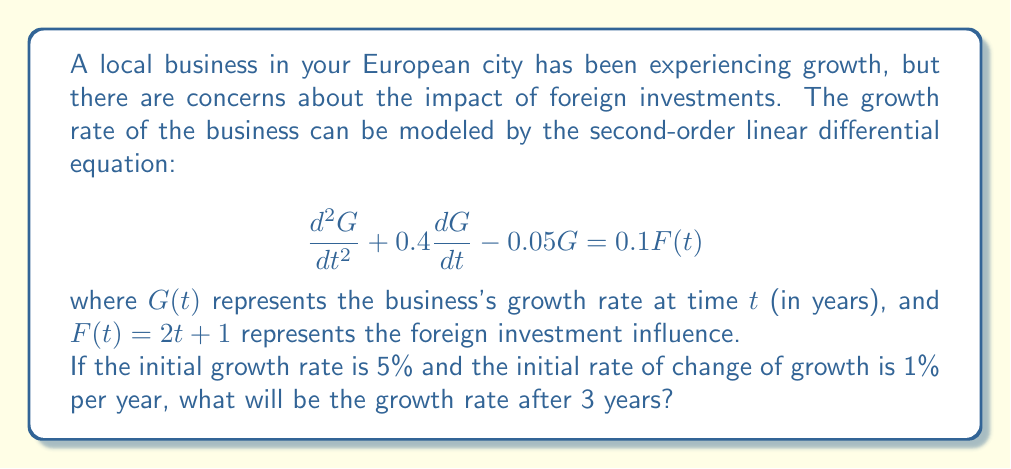Provide a solution to this math problem. To solve this problem, we need to follow these steps:

1) First, we need to find the general solution to the homogeneous equation:

   $$\frac{d^2G}{dt^2} + 0.4\frac{dG}{dt} - 0.05G = 0$$

   The characteristic equation is $r^2 + 0.4r - 0.05 = 0$
   Solving this, we get $r_1 = 0.1$ and $r_2 = -0.5$

   So, the homogeneous solution is:
   $$G_h(t) = c_1e^{0.1t} + c_2e^{-0.5t}$$

2) Now, we need to find a particular solution. Given $F(t) = 2t + 1$, let's assume a particular solution of the form:

   $$G_p(t) = At + B$$

   Substituting this into the original equation:
   
   $$0 + 0.4A - 0.05(At + B) = 0.1(2t + 1)$$

   Equating coefficients:
   $-0.05A = 0.2$
   $0.4A - 0.05B = 0.1$

   Solving these, we get $A = -4$ and $B = -10$

   So, the particular solution is:
   $$G_p(t) = -4t - 10$$

3) The general solution is the sum of the homogeneous and particular solutions:

   $$G(t) = c_1e^{0.1t} + c_2e^{-0.5t} - 4t - 10$$

4) Now we use the initial conditions to find $c_1$ and $c_2$:

   $G(0) = 5$, so $c_1 + c_2 - 10 = 5$
   $G'(0) = 1$, so $0.1c_1 - 0.5c_2 - 4 = 1$

   Solving these equations, we get $c_1 = 20$ and $c_2 = -5$

5) Therefore, the final solution is:

   $$G(t) = 20e^{0.1t} - 5e^{-0.5t} - 4t - 10$$

6) To find the growth rate after 3 years, we simply substitute $t = 3$:

   $$G(3) = 20e^{0.3} - 5e^{-1.5} - 4(3) - 10$$

7) Calculating this gives us the final answer.
Answer: $G(3) \approx 10.86\%$ 